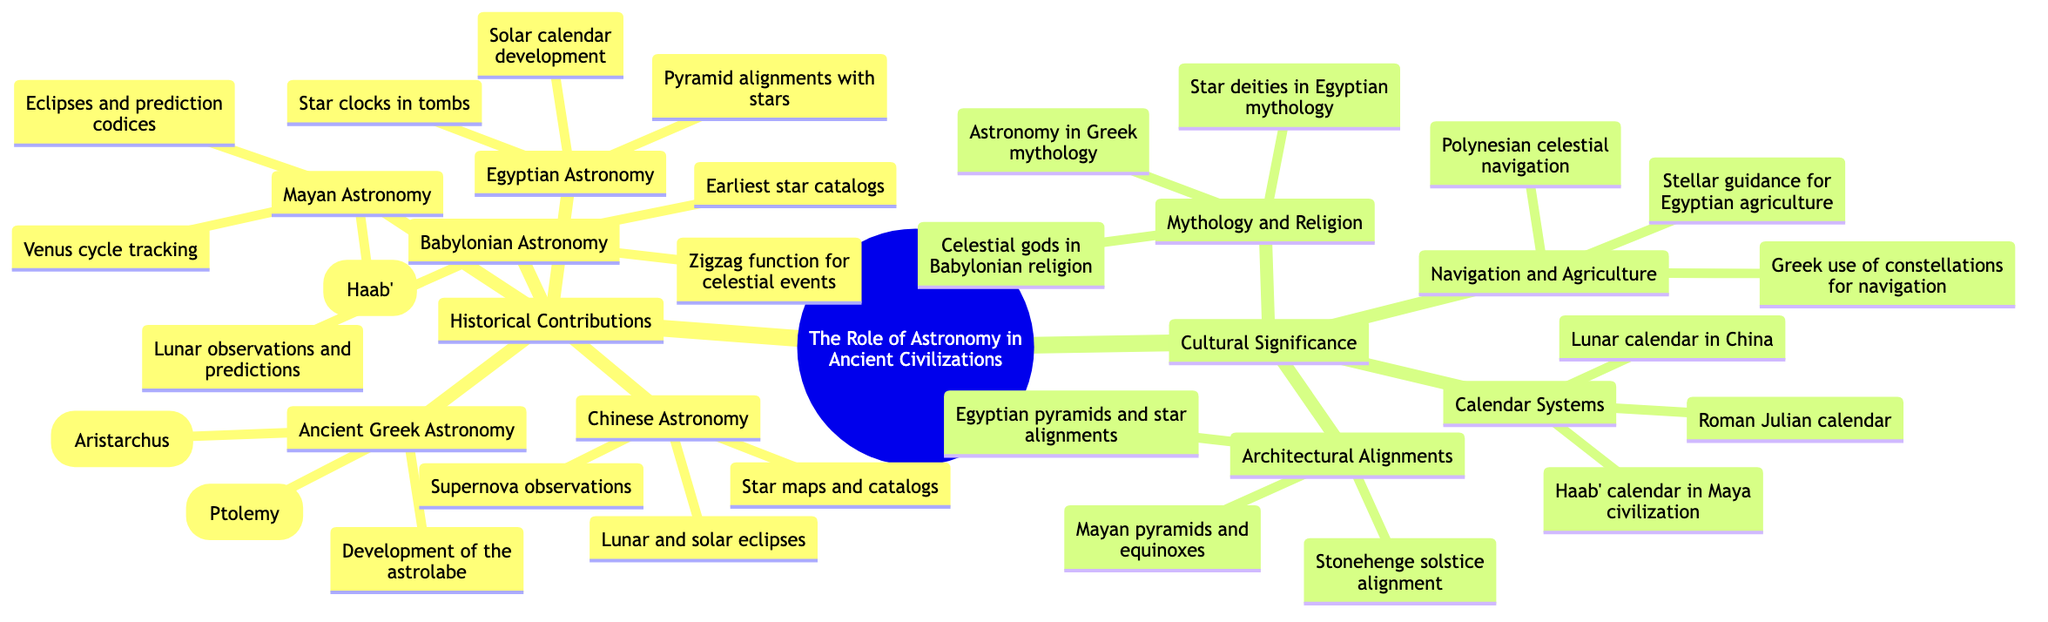What are the key contributions of Babylonian Astronomy? The diagram lists three key points under Babylonian Astronomy: earliest star catalogs, lunar observations and predictions, and the zigzag function for predicting celestial events. These are the significant contributions that are specifically highlighted.
Answer: Earliest star catalogs, lunar observations and predictions, zigzag function for predicting celestial events How many main branches are there in the diagram? The central topic is divided into two main branches: Historical Contributions and Cultural Significance. This can be directly counted from the central node leading into the main branches.
Answer: 2 Which ancient civilization is associated with the heliocentric theory? The diagram indicates that the ancient Greek civilization is connected to the heliocentric theory, specifically attributed to Aristarchus, as a key point in the Ancient Greek Astronomy branch.
Answer: Ancient Greek Astronomy What calendar system is associated with the Mayan civilization? According to the diagram, the Haab’ calendar is explicitly mentioned as a key point under the Mayan Astronomy sub-branch, indicating their calendar system.
Answer: Haab' calendar Which astronomical observation is noted in Chinese Astronomy? The diagram includes supernova observations as a key point under the Chinese Astronomy sub-branch, highlighting their contributions in this area.
Answer: Supernova observations How many key points are listed under Egyptian Astronomy? There are three key points mentioned under the Egyptian Astronomy sub-branch: pyramid alignments with stars, solar calendar development, and star clocks in tombs. This can be counted directly from the diagram.
Answer: 3 What is a cultural significance related to mythology found under this diagram? Under Cultural Significance, in the Mythology and Religion sub-branch, astronomy in Greek mythology is listed as a key point, showcasing its relevance in ancient cultures.
Answer: Astronomy in Greek mythology Which civilization practiced celestial navigation according to the diagram? The Polynesian civilization is mentioned in the Navigation and Agriculture sub-branch, indicating their practice of celestial navigation as a significant cultural aspect.
Answer: Polynesian celestial navigation What is the architectural feature associated with Stonehenge? The diagram indicates that Stonehenge has a solstice alignment, which is stated as a key point in the Architectural Alignments sub-branch, linking it to astronomy.
Answer: Solstice alignment 